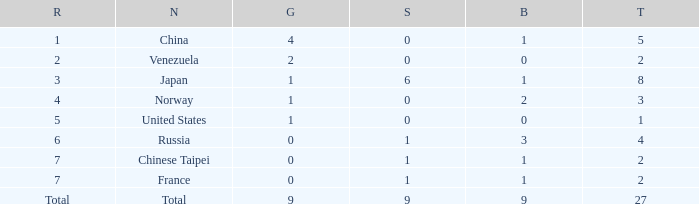What is the total number of Bronze when gold is more than 1 and nation is total? 1.0. 